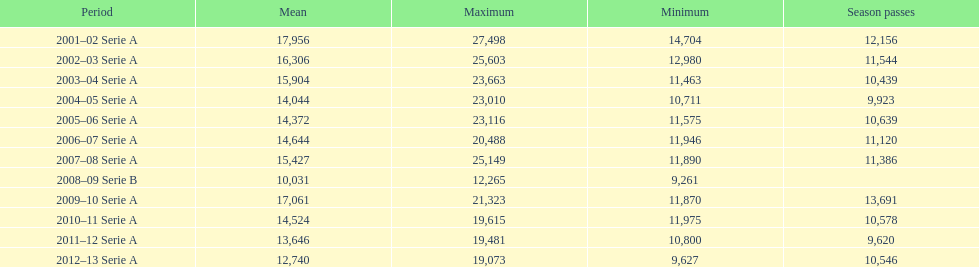What was the average attendance in 2008? 10,031. 